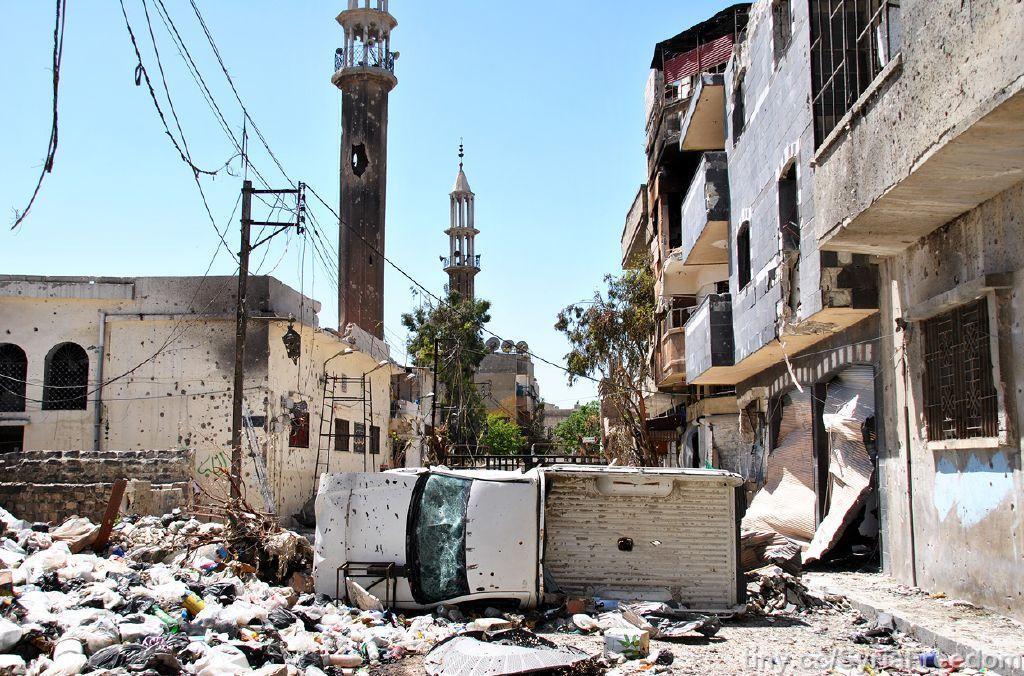Please provide a concise description of this image. In this image we can see buildings under excavation, dumping yard, towers, electric poles, electric cables, trees and sky. 